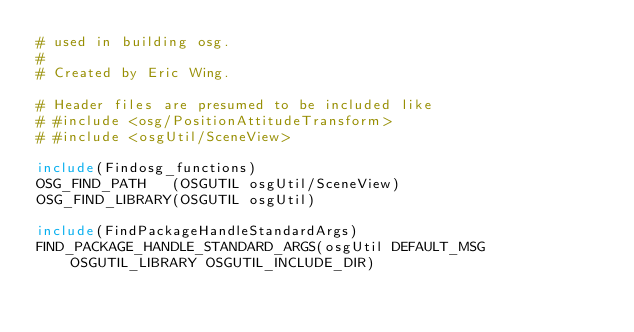<code> <loc_0><loc_0><loc_500><loc_500><_CMake_># used in building osg.
#
# Created by Eric Wing.

# Header files are presumed to be included like
# #include <osg/PositionAttitudeTransform>
# #include <osgUtil/SceneView>

include(Findosg_functions)
OSG_FIND_PATH   (OSGUTIL osgUtil/SceneView)
OSG_FIND_LIBRARY(OSGUTIL osgUtil)

include(FindPackageHandleStandardArgs)
FIND_PACKAGE_HANDLE_STANDARD_ARGS(osgUtil DEFAULT_MSG
    OSGUTIL_LIBRARY OSGUTIL_INCLUDE_DIR)
</code> 